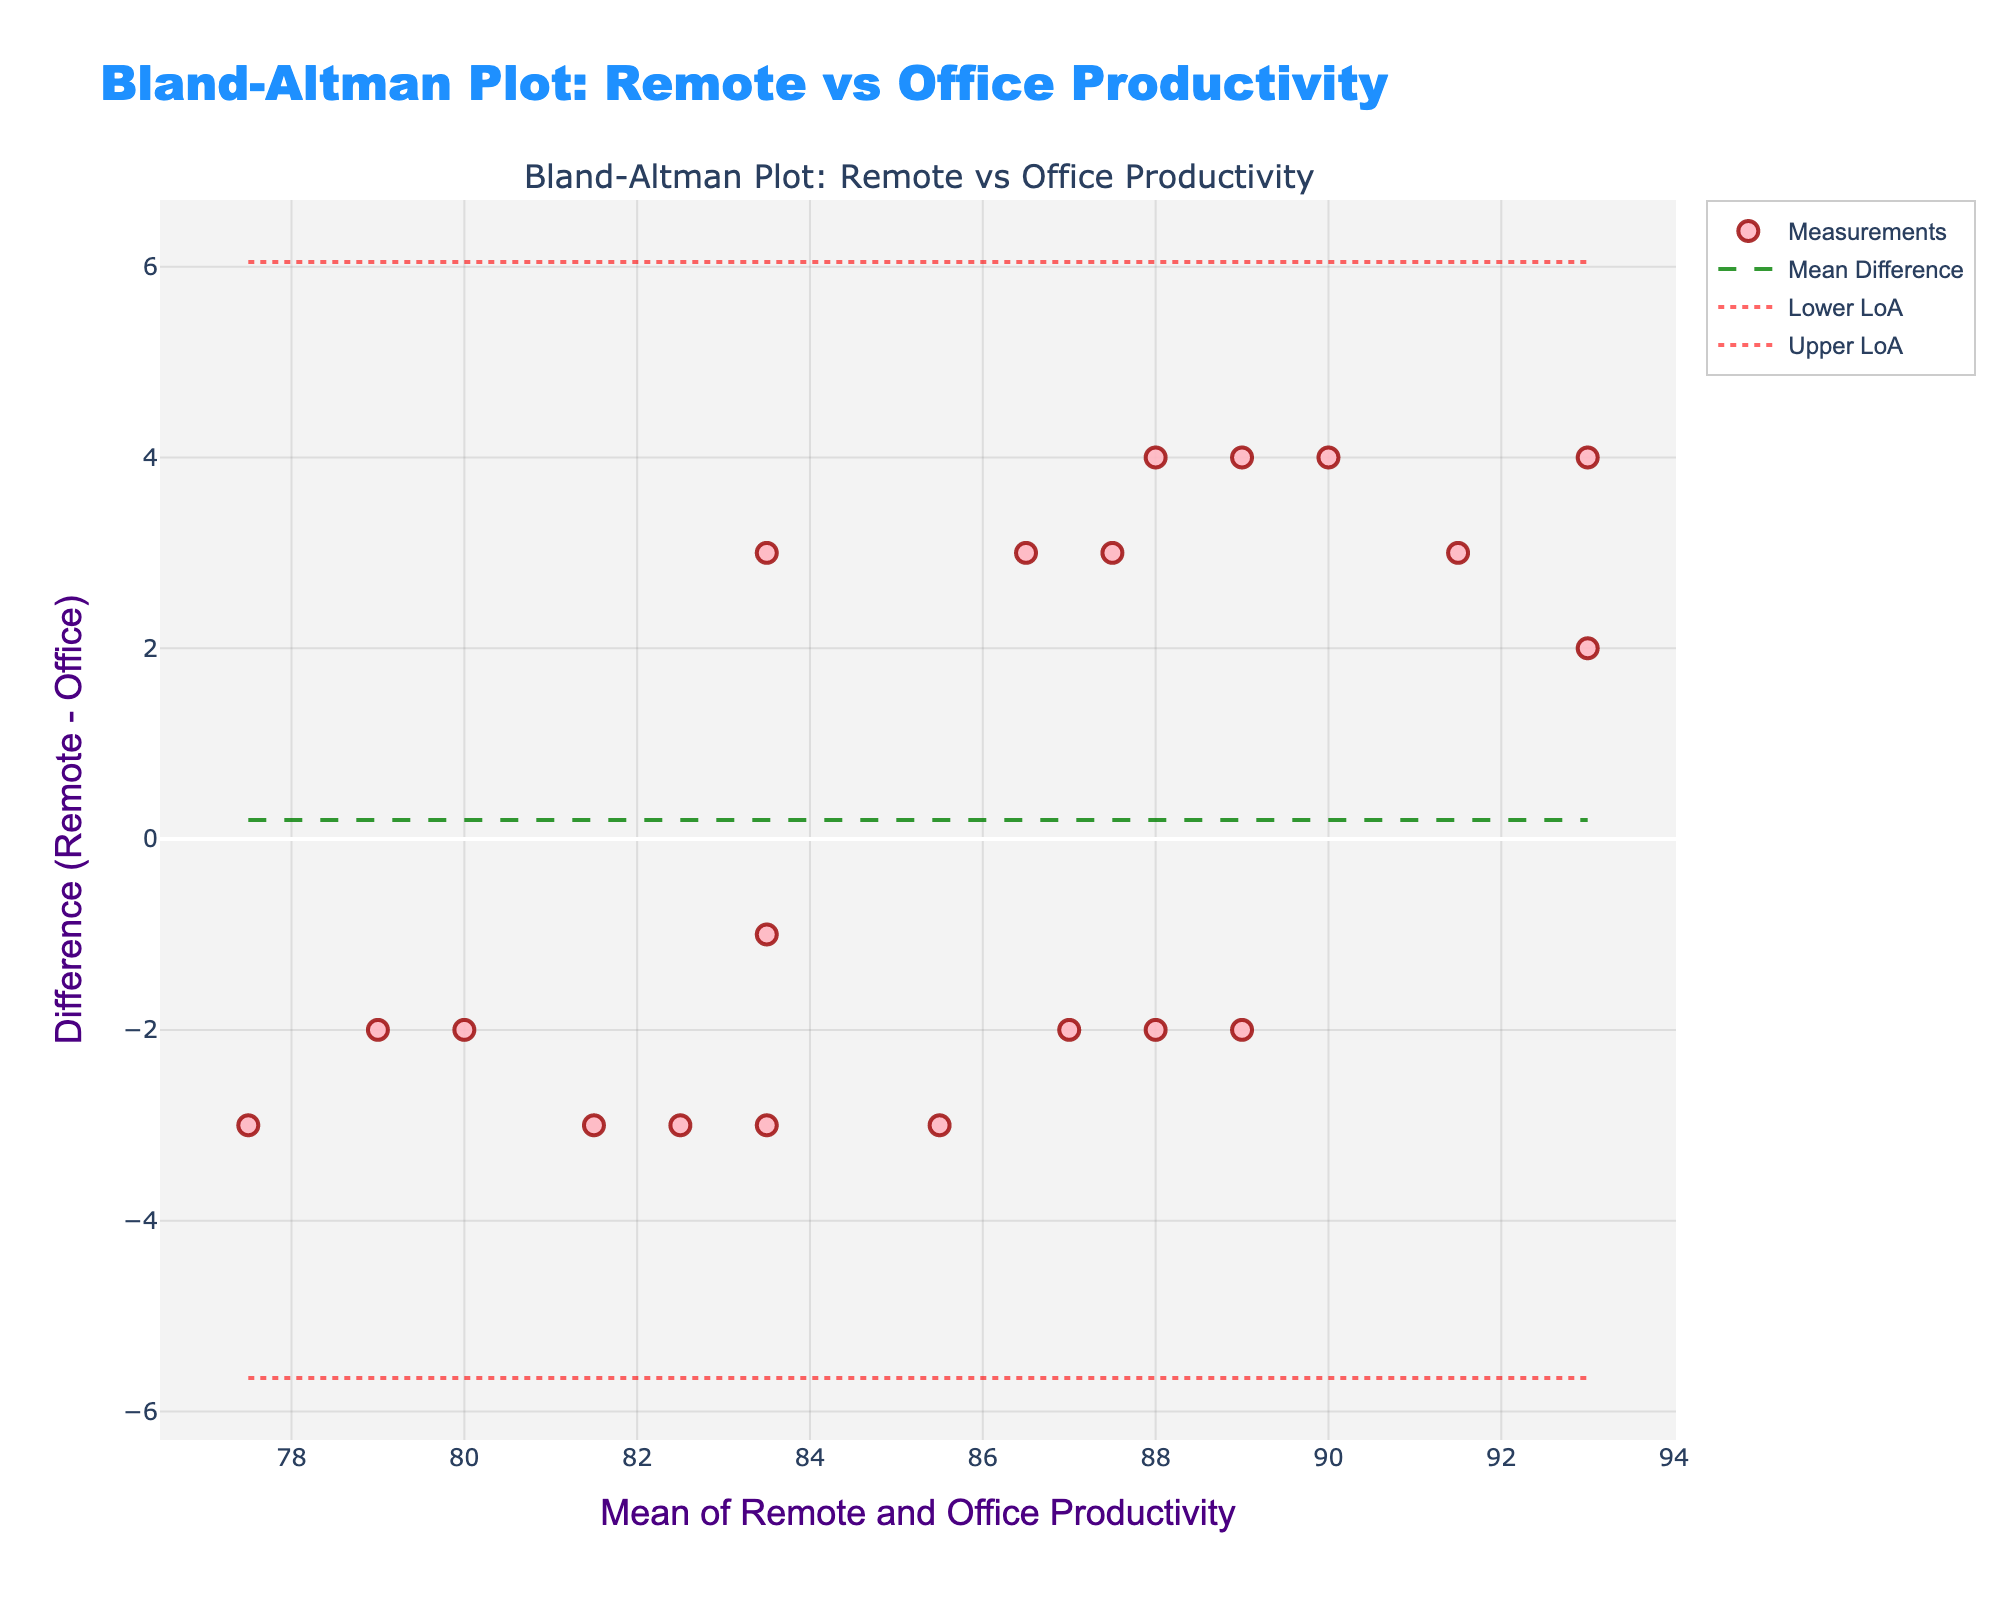which title is shown on the Bland–Altman plot? The title is found at the top of the plot in large font. It is "Bland-Altman Plot: Remote vs Office Productivity". This indicates that the plot compares remote and office productivity metrics.
Answer: Bland-Altman Plot: Remote vs Office Productivity What does the x-axis represent? The x-axis title is "Mean of Remote and Office Productivity", which is computed by averaging the productivity metrics of remote and office working environments for each employee.
Answer: Mean of Remote and Office Productivity How many data points are displayed in the plot? Each point on the plot represents an employee with their mean remote and office productivity and the difference between their remote and office productivity. Since there are 20 data lines representing 20 employees, there are 20 data points in the plot.
Answer: 20 What is the color of the Mean Difference line? The Mean Difference line represents the average difference between remote and office productivity. From the plot, it is drawn as a dashed line colored in a dark green shade.
Answer: Dark green Are there any data points that fall outside the limits of agreement? Check if any of the scattered data points are beyond the upper or lower dotted lines (Limits of Agreement). The visual inspection shows no data points outside these lines, suggesting all employee productivity differences are within accepted limits.
Answer: No Between which productivity means do most of the data points cluster? To determine where most data points cluster, observe where the highest concentration of scatter points lies on the mean (x) axis. Most points seem to fall in the range of 85 to 93 average productivity.
Answer: 85 to 93 Which employee shows the largest positive difference between remote and office productivity? To find the largest positive difference, look at the highest point on the y-axis where the difference value is positive and note the employee associated with this point. This would need identification from the underlying data if labeled.
Answer: Identify from data table What does it imply if the mean difference line is close to zero? When the mean difference line (green dashed line) is close to zero, it implies that, on average, remote and office productivity are similar across employees, with no significant bias towards either work condition.
Answer: Similar productivity 